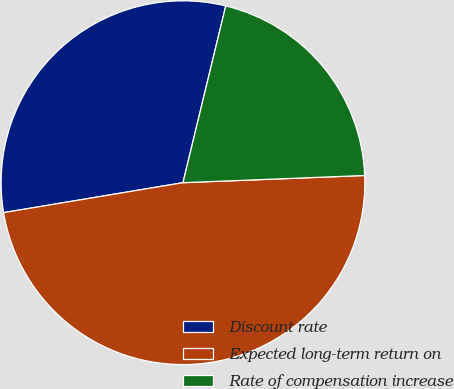<chart> <loc_0><loc_0><loc_500><loc_500><pie_chart><fcel>Discount rate<fcel>Expected long-term return on<fcel>Rate of compensation increase<nl><fcel>31.41%<fcel>48.0%<fcel>20.59%<nl></chart> 